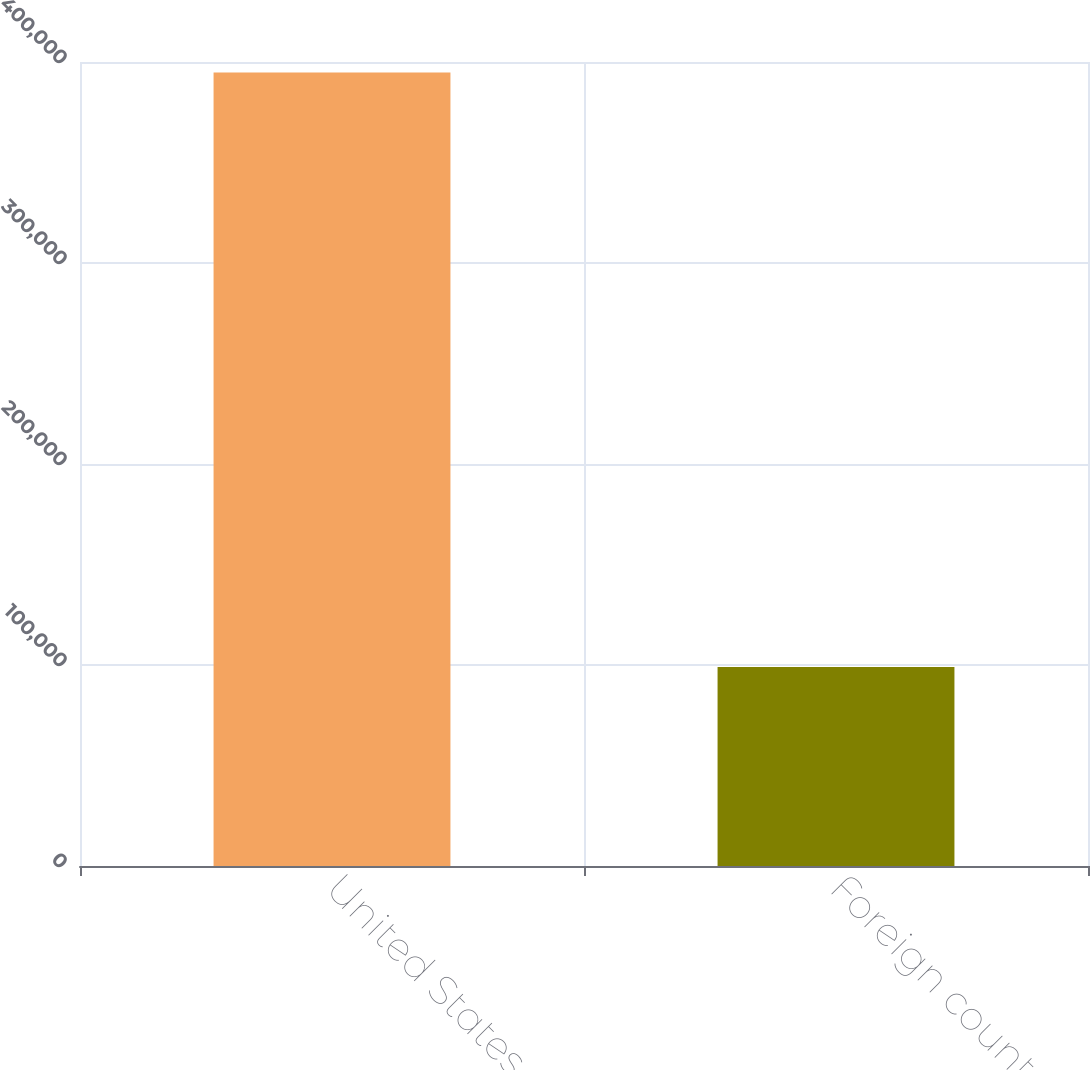Convert chart to OTSL. <chart><loc_0><loc_0><loc_500><loc_500><bar_chart><fcel>United States<fcel>Foreign countries<nl><fcel>394716<fcel>98962<nl></chart> 